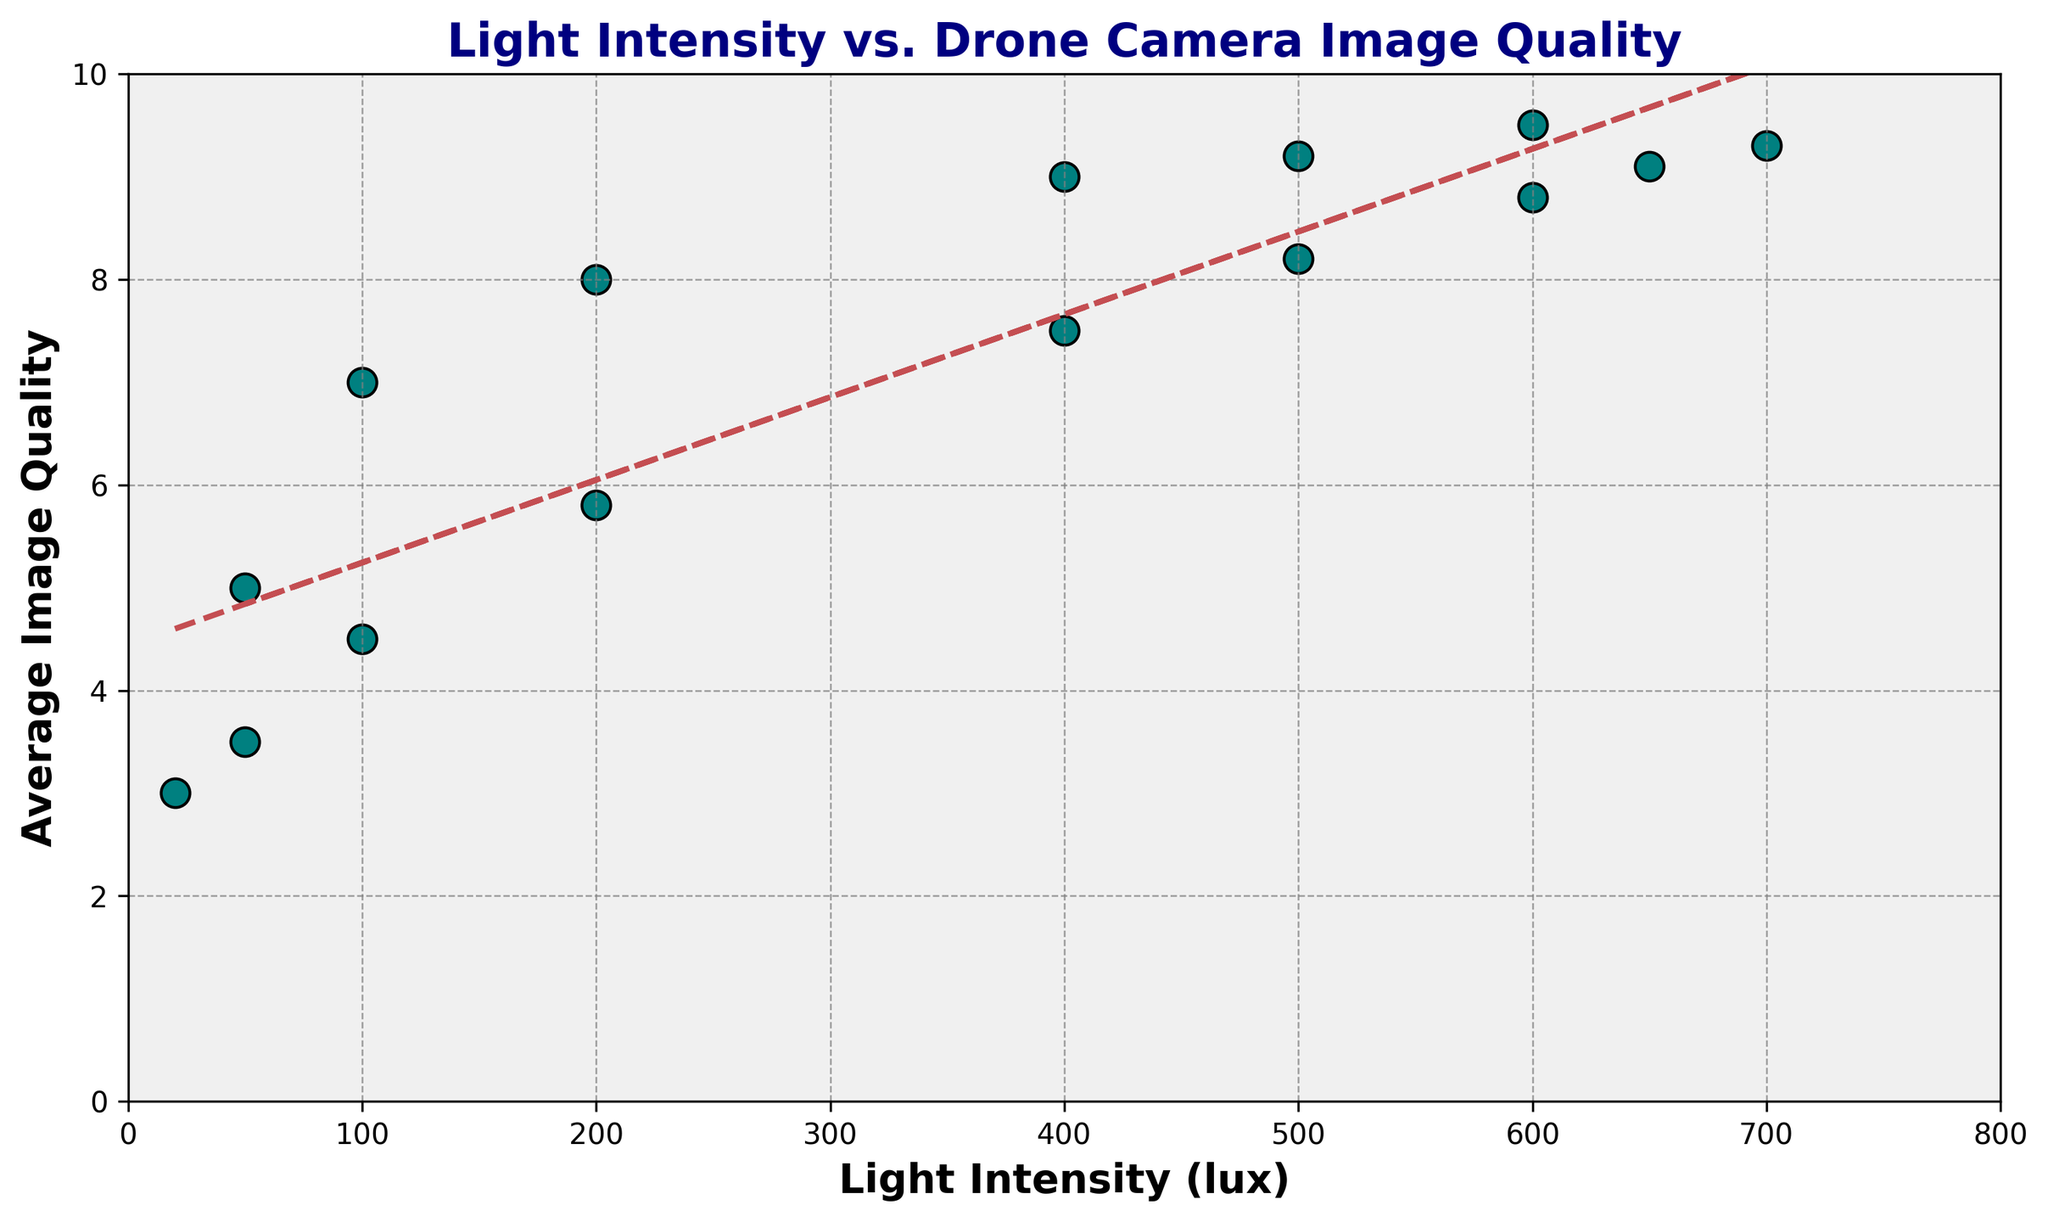What's the highest average image quality value in the plot? The plot shows different points for average image quality data. By examining these points, the highest value observed on the y-axis is 9.5.
Answer: 9.5 At what light intensity does the highest average image quality occur? By finding the point with the highest average image quality (9.5), we can trace it back to the x-axis to find the corresponding light intensity, which is 600 lux.
Answer: 600 lux How does the average image quality change from 06:00 to 12:00? Starting at 20 lux with average image quality of 3, the average image quality increases steadily as the light intensity rises, reaching 9.5 at 600 lux by 12:00, indicating a positive correlation.
Answer: It increases At what time of day does the light intensity begin to decrease after reaching its peak? By examining the scatter plot and noting the highest light intensity (700 lux) at 13:00, we can see that light intensity decreases afterward.
Answer: 13:00 Which time of day corresponds to an average image quality of 8.8? Locating the point on the plot with an average image quality of 8.8, we can trace it back to its corresponding light intensity (600 lux) and then check the data to find that it is at 15:00.
Answer: 15:00 What is the general trend of the trendline added to the plot? By observing the red dashed trendline in the scatter plot, it generally slopes upward, indicating a positive correlation between light intensity and average image quality.
Answer: Positive correlation At what light intensity does the average image quality start to decrease again after peaking? After reaching a maximum at 12:00 (600 lux, quality 9.5), the average image quality slightly decreases as light intensity remains high or decreases, starting a noticeable drop around 17:00 (200 lux, quality 5.8).
Answer: 700-600 lux Is there any significant dip in the average image quality throughout the day? If so, at what light intensity does it occur? Scanning the scatter plot points, there's a notable dip seen in the evening where the light intensity drops to 50 lux and image quality reduces to 3.5.
Answer: 50 lux 